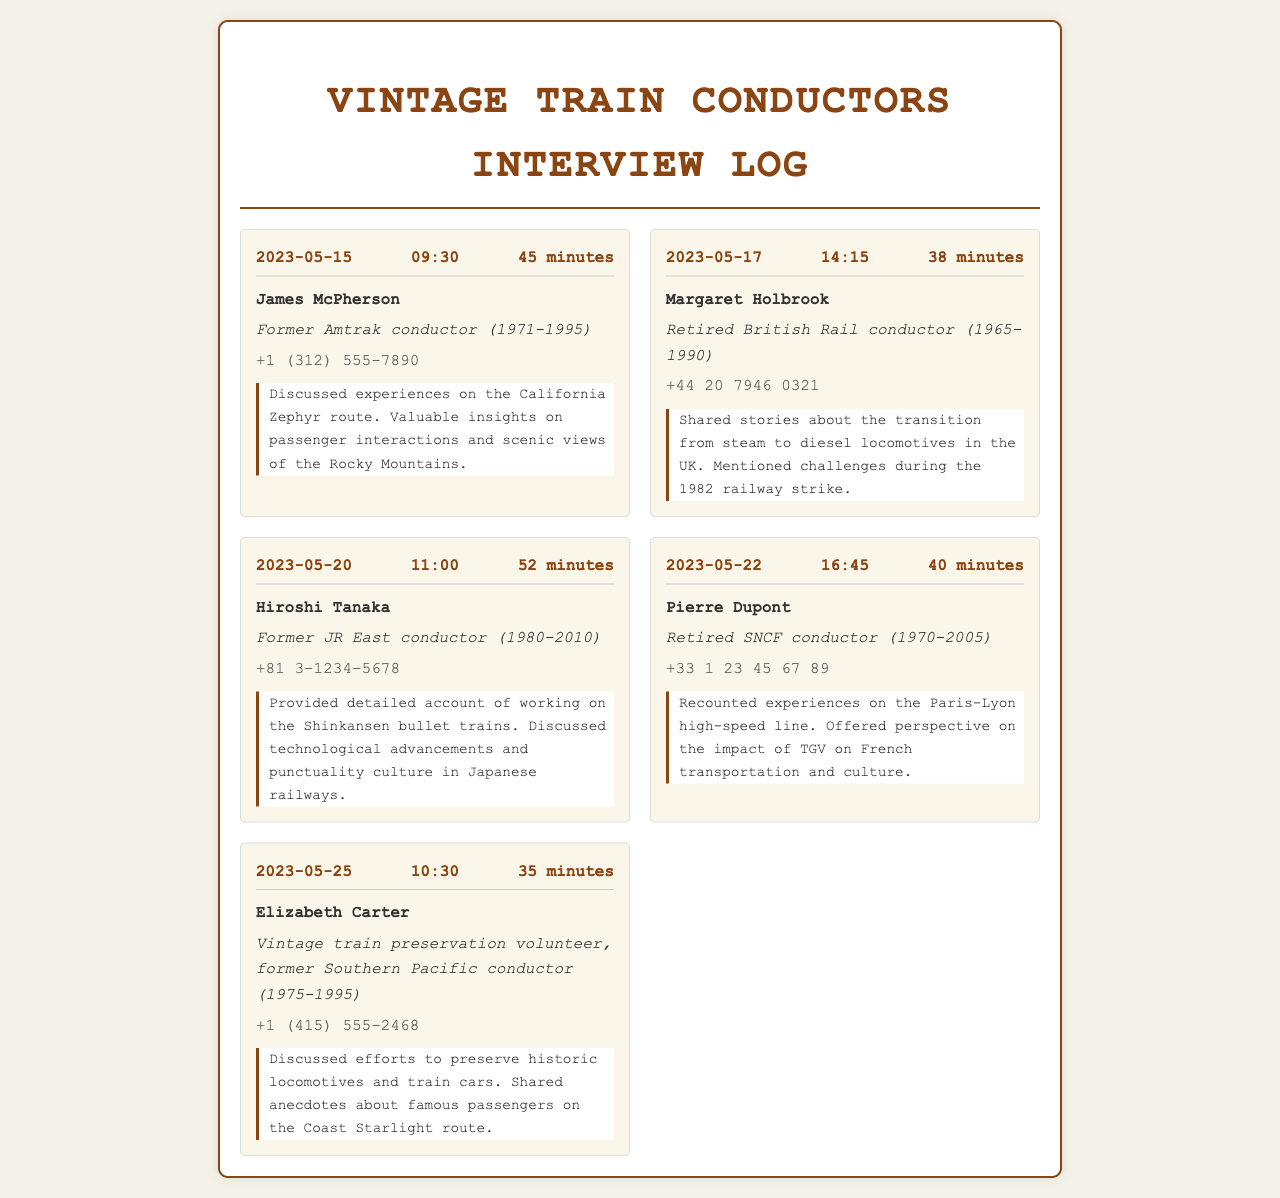what is the date of the first interview? The first interview in the log is on May 15, 2023.
Answer: May 15, 2023 who was the conductor interviewed on May 20, 2023? The conductor interviewed on this date was Hiroshi Tanaka.
Answer: Hiroshi Tanaka how long was the call with Margaret Holbrook? The call duration with Margaret Holbrook was 38 minutes.
Answer: 38 minutes which conductor discussed experiences on the Paris-Lyon high-speed line? Pierre Dupont shared experiences on the Paris-Lyon high-speed line.
Answer: Pierre Dupont what was the primary topic of discussion in James McPherson's interview? James McPherson discussed experiences on the California Zephyr route.
Answer: California Zephyr route who is the vintage train preservation volunteer mentioned in the log? Elizabeth Carter is the vintage train preservation volunteer mentioned.
Answer: Elizabeth Carter how many minutes was the call with Hiroshi Tanaka? The call with Hiroshi Tanaka lasted for 52 minutes.
Answer: 52 minutes what is the phone number of Margaret Holbrook? Margaret Holbrook's phone number is +44 20 7946 0321.
Answer: +44 20 7946 0321 what is the relationship of Elizabeth Carter to vintage trains? Elizabeth Carter is a vintage train preservation volunteer and former conductor.
Answer: vintage train preservation volunteer 